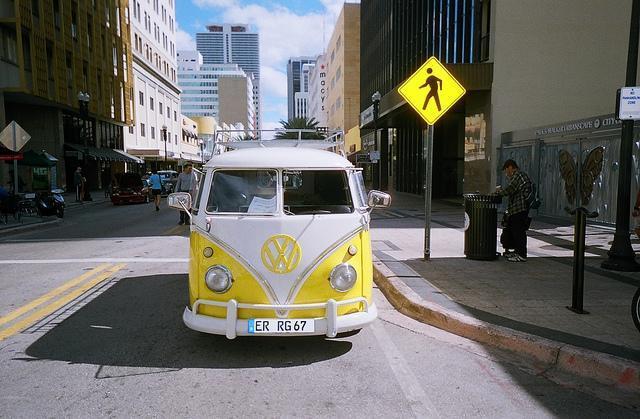How many elephants are there?
Give a very brief answer. 0. 